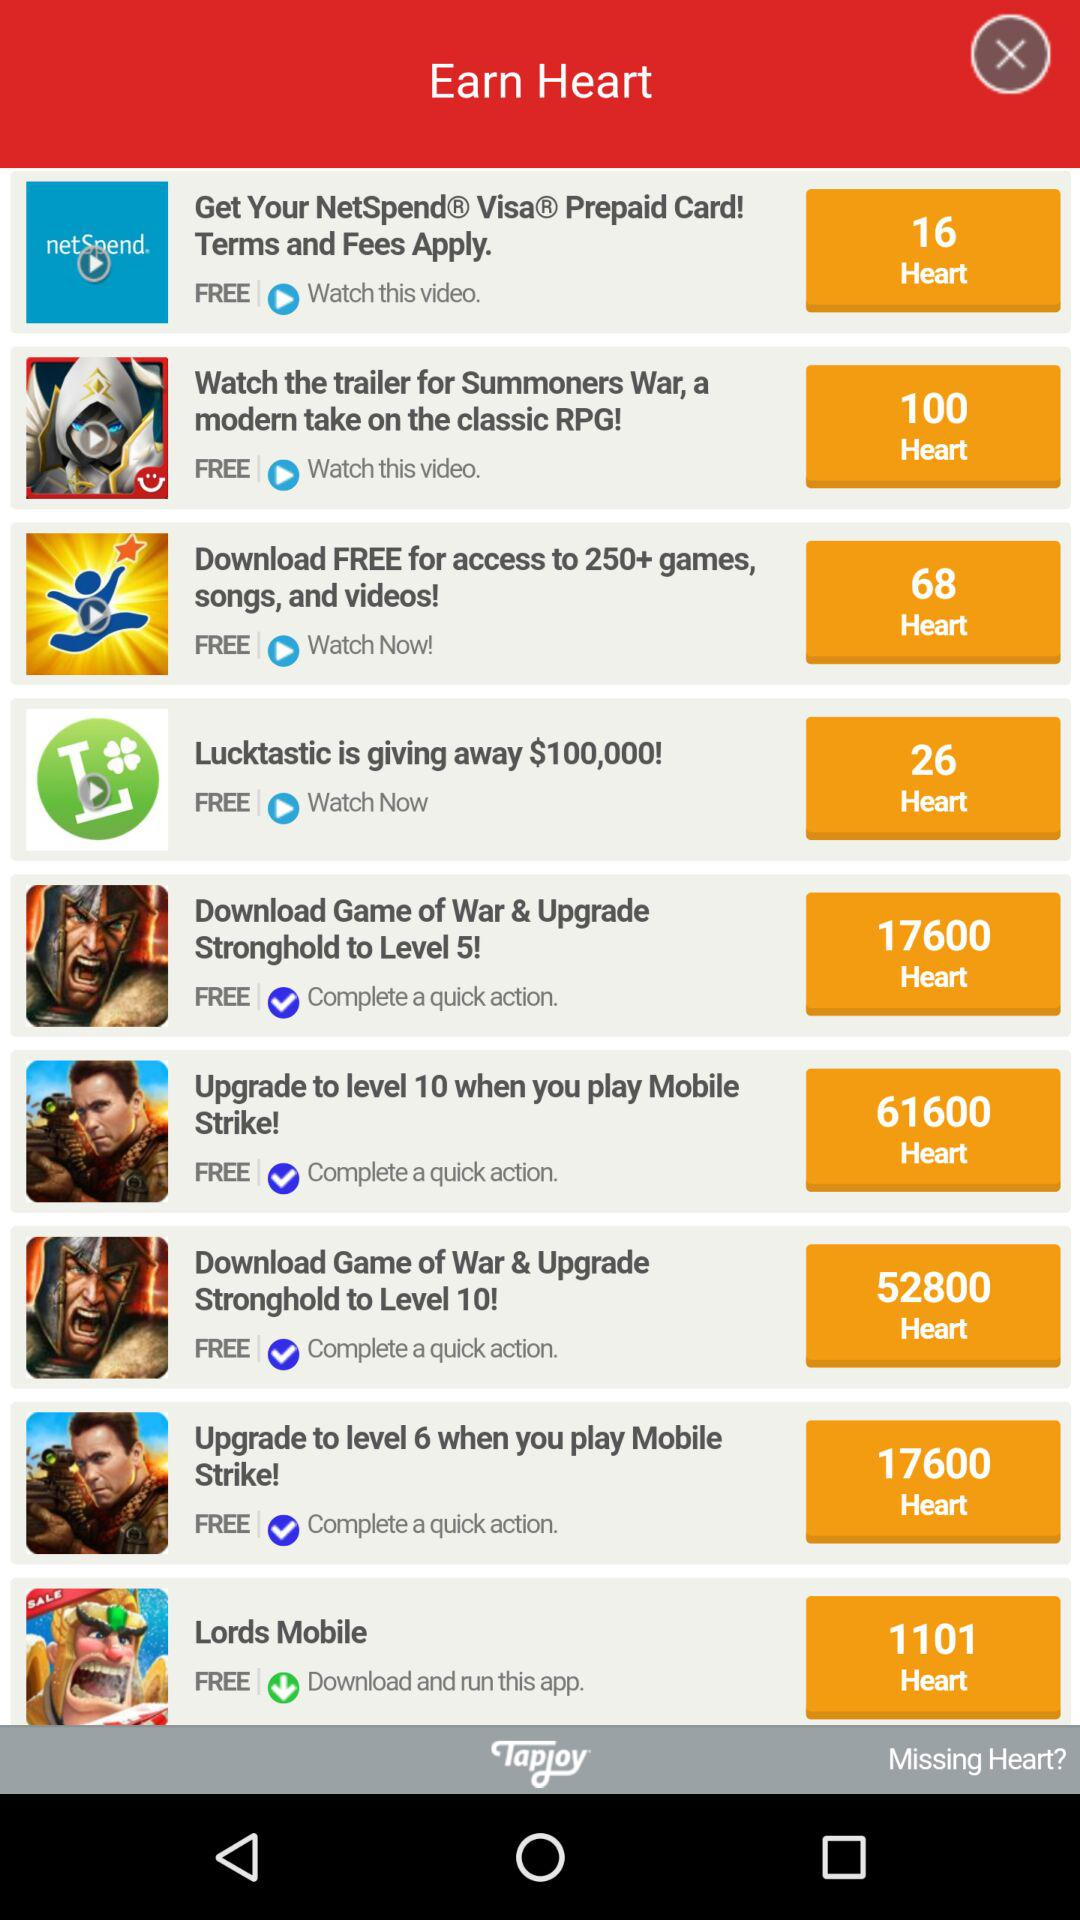Which game can we download to earn 17600 hearts? You can download "Game of War" to earn 17600 hearts. 